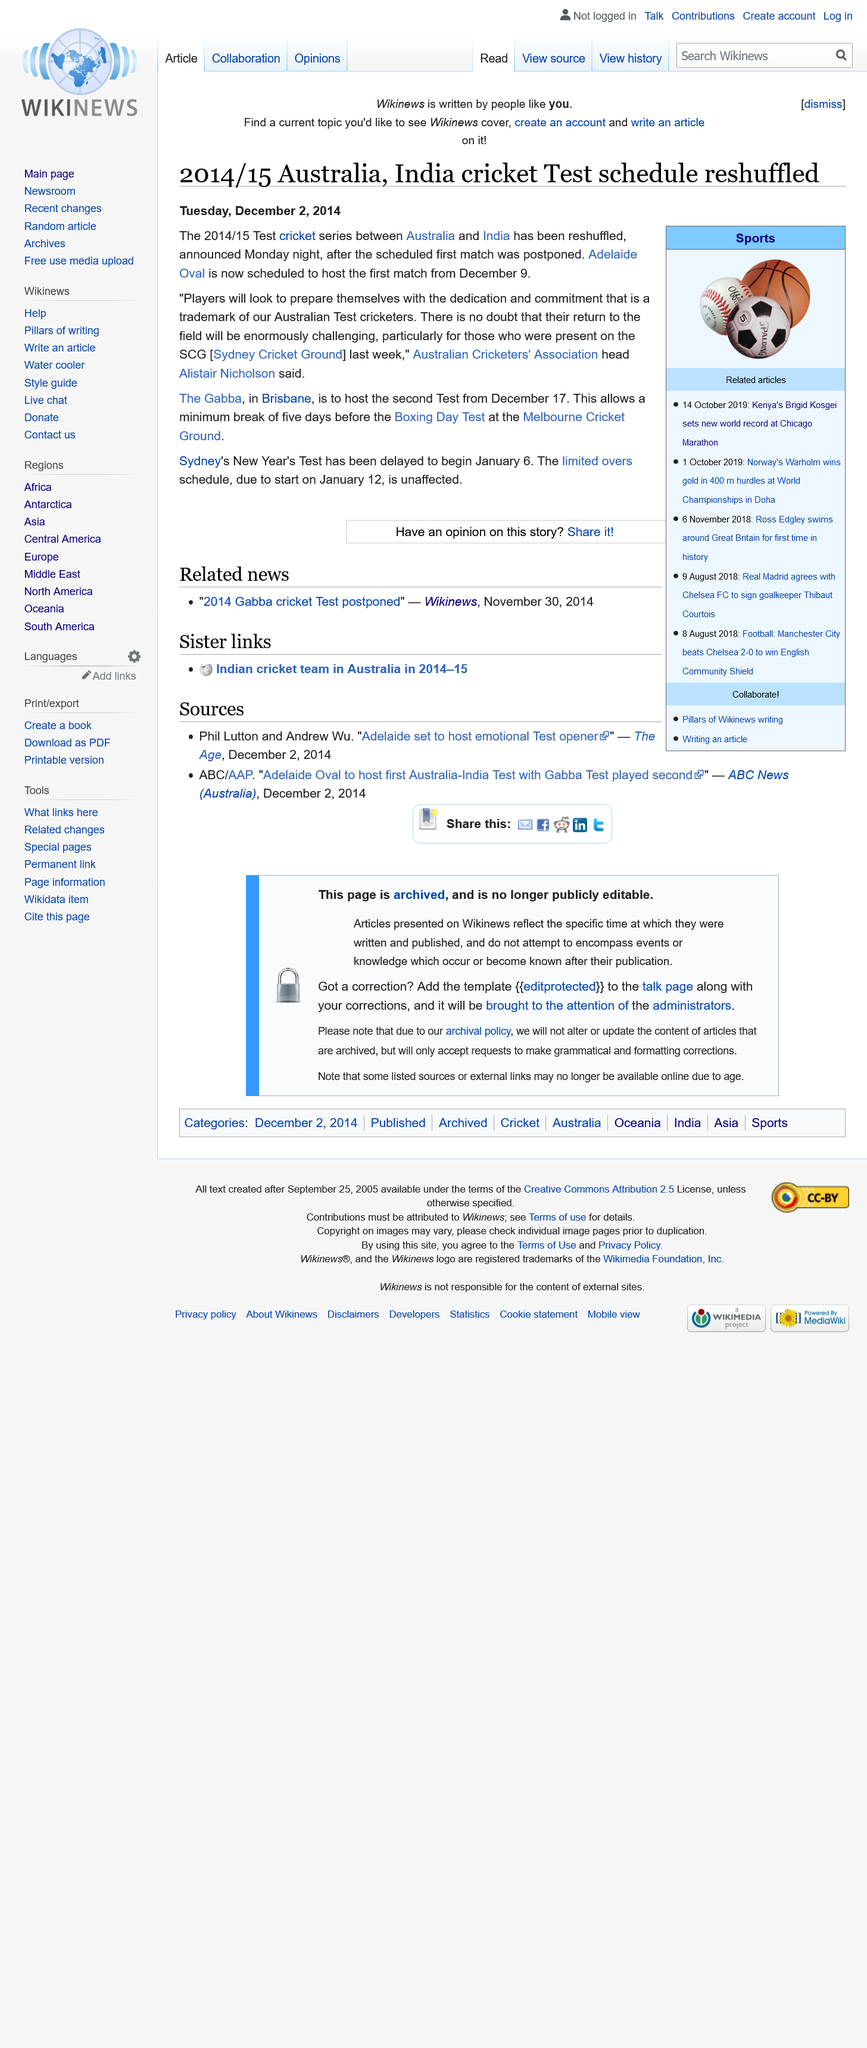List a handful of essential elements in this visual. The acronym SCG stands for Sydney Cricket Ground, a prominent sports stadium located in Sydney, Australia. The Boxing Day Test will be held at the Melbourne Cricket Ground. The Gabba cricket ground is located in Brisbane. 